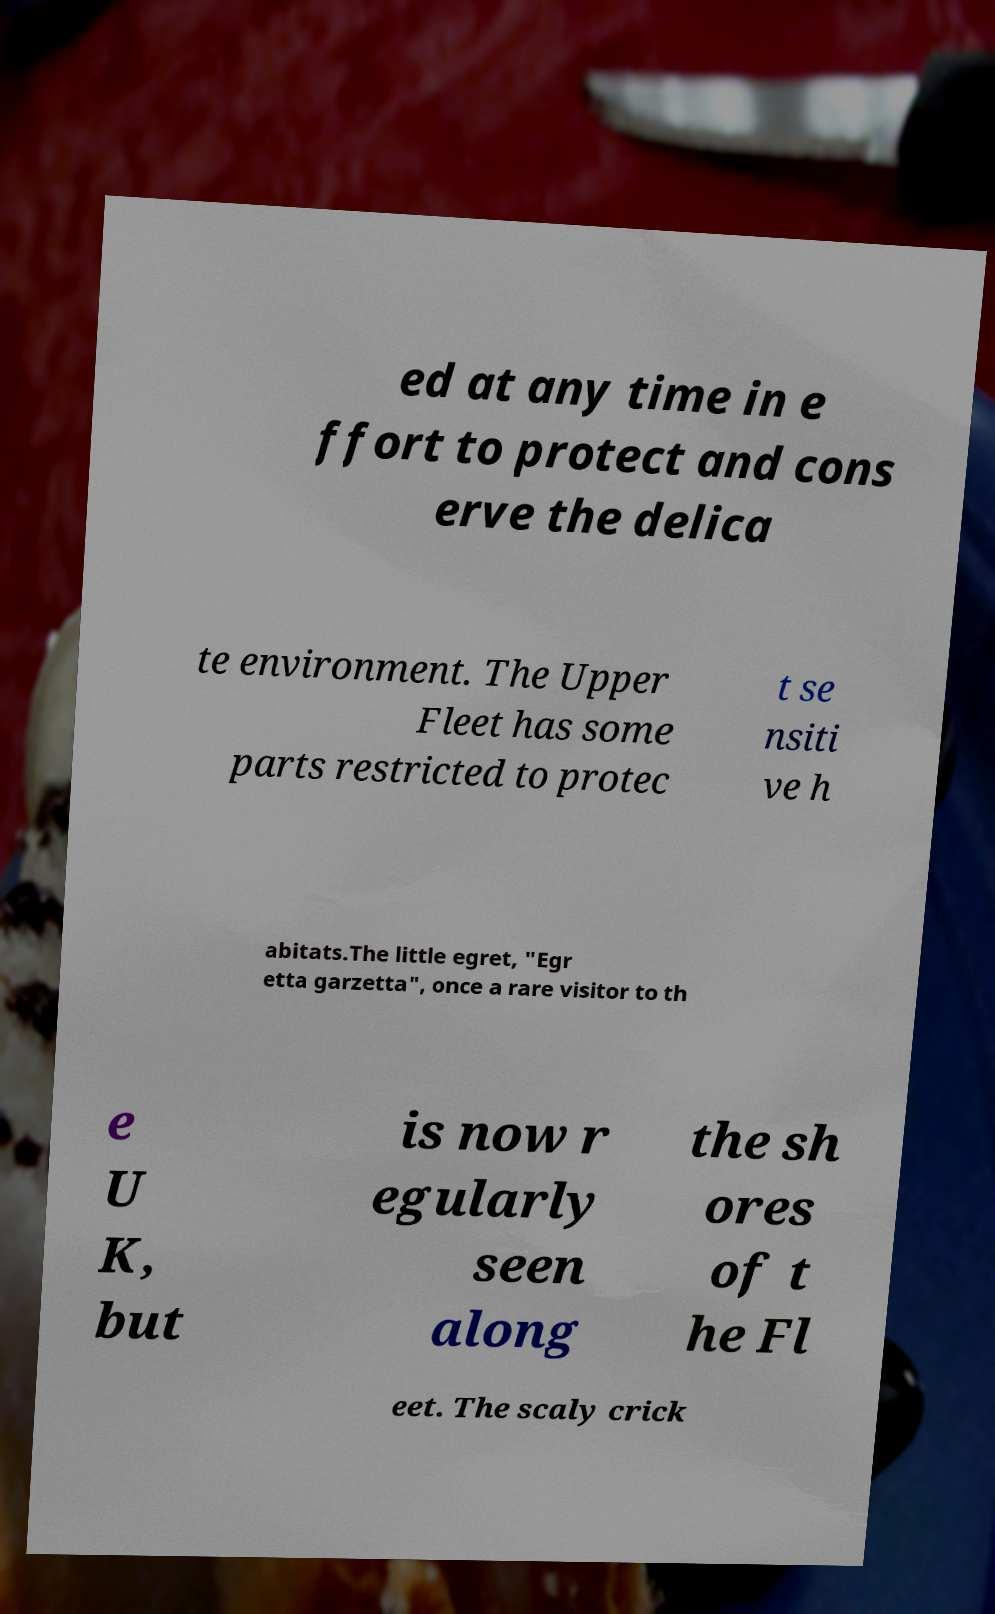Could you extract and type out the text from this image? ed at any time in e ffort to protect and cons erve the delica te environment. The Upper Fleet has some parts restricted to protec t se nsiti ve h abitats.The little egret, "Egr etta garzetta", once a rare visitor to th e U K, but is now r egularly seen along the sh ores of t he Fl eet. The scaly crick 